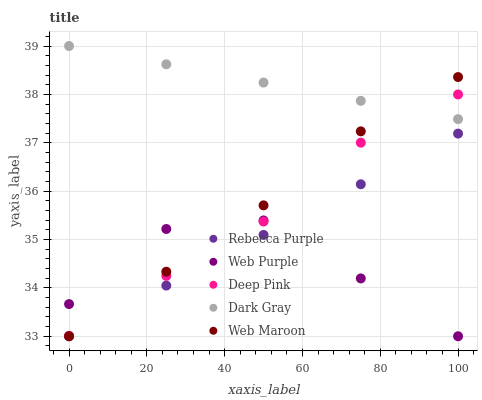Does Web Purple have the minimum area under the curve?
Answer yes or no. Yes. Does Dark Gray have the maximum area under the curve?
Answer yes or no. Yes. Does Deep Pink have the minimum area under the curve?
Answer yes or no. No. Does Deep Pink have the maximum area under the curve?
Answer yes or no. No. Is Dark Gray the smoothest?
Answer yes or no. Yes. Is Web Purple the roughest?
Answer yes or no. Yes. Is Deep Pink the smoothest?
Answer yes or no. No. Is Deep Pink the roughest?
Answer yes or no. No. Does Web Purple have the lowest value?
Answer yes or no. Yes. Does Deep Pink have the lowest value?
Answer yes or no. No. Does Dark Gray have the highest value?
Answer yes or no. Yes. Does Deep Pink have the highest value?
Answer yes or no. No. Is Web Purple less than Dark Gray?
Answer yes or no. Yes. Is Dark Gray greater than Rebecca Purple?
Answer yes or no. Yes. Does Deep Pink intersect Web Purple?
Answer yes or no. Yes. Is Deep Pink less than Web Purple?
Answer yes or no. No. Is Deep Pink greater than Web Purple?
Answer yes or no. No. Does Web Purple intersect Dark Gray?
Answer yes or no. No. 